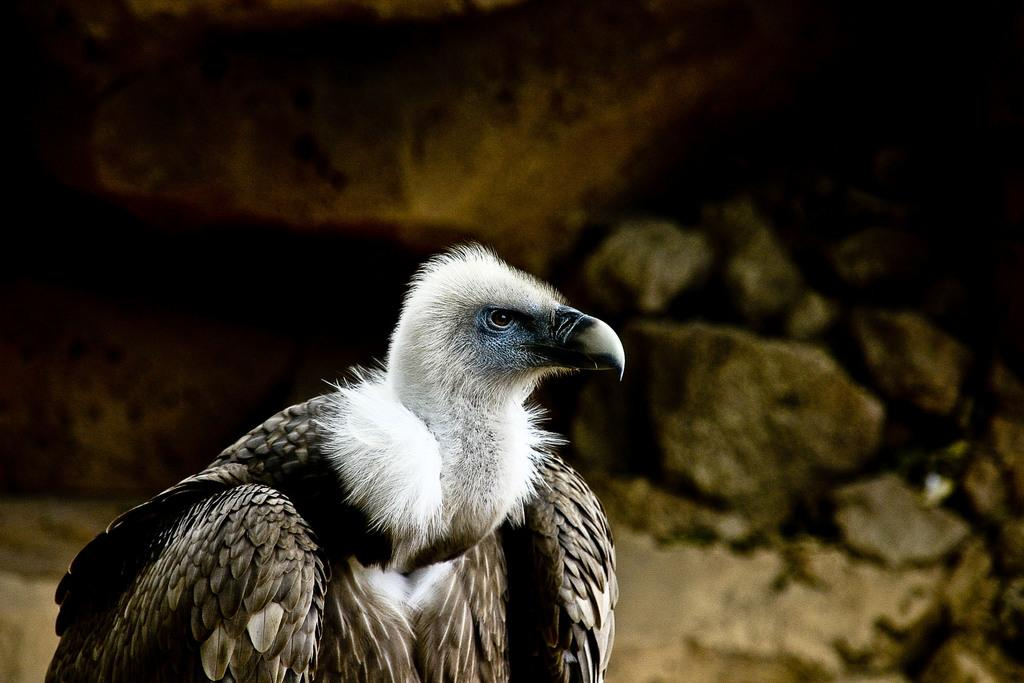What type of bird is in the image? There is a vulture in the image. What can be seen in the background of the image? There are stones in the background of the image. Where is the lake located in the image? There is no lake present in the image; it features a vulture and stones in the background. Can you describe the canvas on which the vulture is painted? The image is not a painting, so there is no canvas present. 